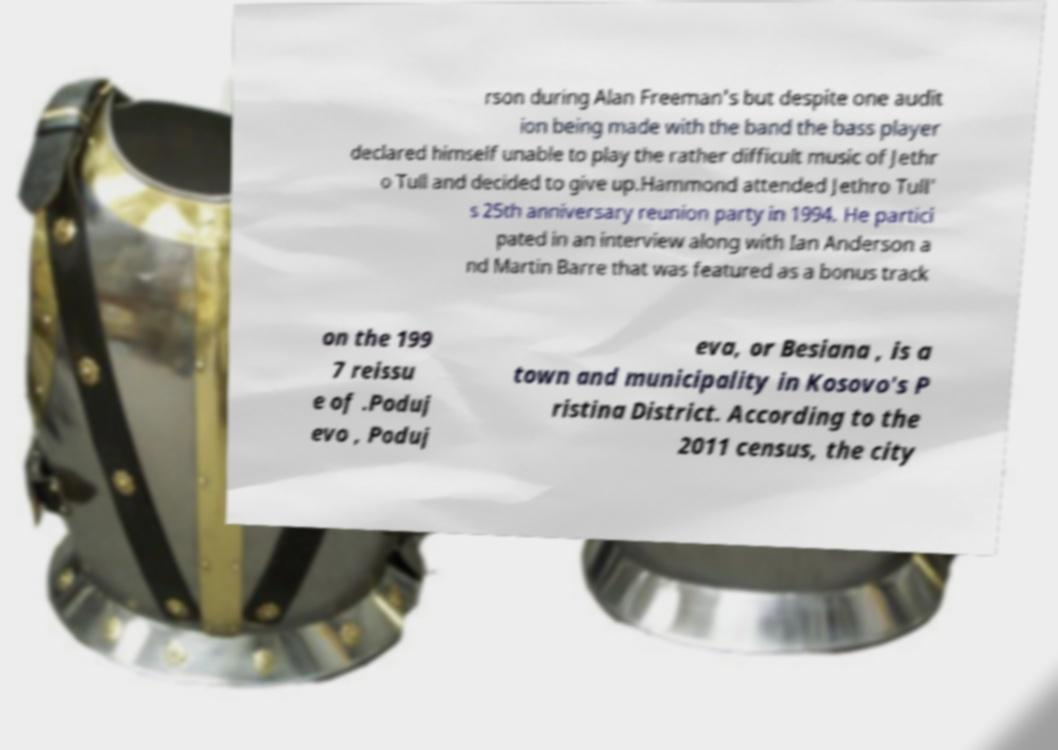Can you read and provide the text displayed in the image?This photo seems to have some interesting text. Can you extract and type it out for me? rson during Alan Freeman's but despite one audit ion being made with the band the bass player declared himself unable to play the rather difficult music of Jethr o Tull and decided to give up.Hammond attended Jethro Tull' s 25th anniversary reunion party in 1994. He partici pated in an interview along with Ian Anderson a nd Martin Barre that was featured as a bonus track on the 199 7 reissu e of .Poduj evo , Poduj eva, or Besiana , is a town and municipality in Kosovo's P ristina District. According to the 2011 census, the city 